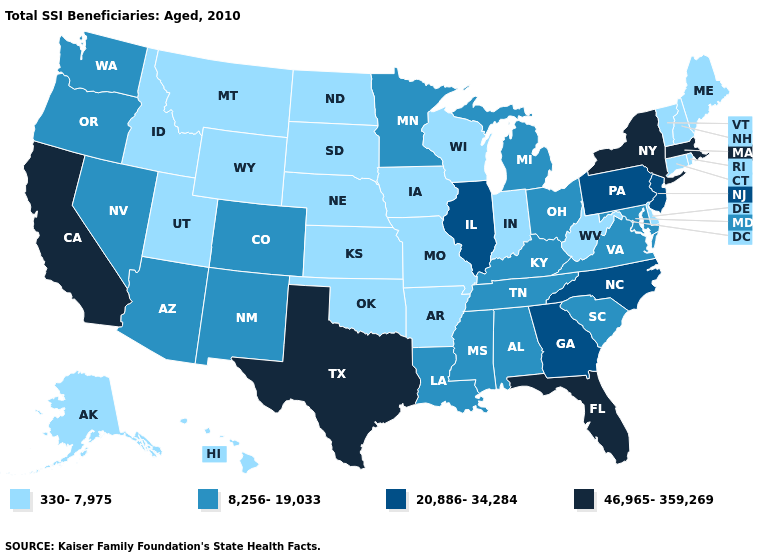Name the states that have a value in the range 8,256-19,033?
Answer briefly. Alabama, Arizona, Colorado, Kentucky, Louisiana, Maryland, Michigan, Minnesota, Mississippi, Nevada, New Mexico, Ohio, Oregon, South Carolina, Tennessee, Virginia, Washington. What is the highest value in the USA?
Short answer required. 46,965-359,269. Does North Carolina have the lowest value in the USA?
Keep it brief. No. What is the lowest value in states that border Vermont?
Concise answer only. 330-7,975. Name the states that have a value in the range 8,256-19,033?
Give a very brief answer. Alabama, Arizona, Colorado, Kentucky, Louisiana, Maryland, Michigan, Minnesota, Mississippi, Nevada, New Mexico, Ohio, Oregon, South Carolina, Tennessee, Virginia, Washington. Does the first symbol in the legend represent the smallest category?
Answer briefly. Yes. Name the states that have a value in the range 330-7,975?
Quick response, please. Alaska, Arkansas, Connecticut, Delaware, Hawaii, Idaho, Indiana, Iowa, Kansas, Maine, Missouri, Montana, Nebraska, New Hampshire, North Dakota, Oklahoma, Rhode Island, South Dakota, Utah, Vermont, West Virginia, Wisconsin, Wyoming. Name the states that have a value in the range 8,256-19,033?
Write a very short answer. Alabama, Arizona, Colorado, Kentucky, Louisiana, Maryland, Michigan, Minnesota, Mississippi, Nevada, New Mexico, Ohio, Oregon, South Carolina, Tennessee, Virginia, Washington. Which states have the lowest value in the West?
Answer briefly. Alaska, Hawaii, Idaho, Montana, Utah, Wyoming. Does the first symbol in the legend represent the smallest category?
Short answer required. Yes. Among the states that border Idaho , which have the highest value?
Be succinct. Nevada, Oregon, Washington. Does Illinois have a lower value than Arizona?
Give a very brief answer. No. Name the states that have a value in the range 46,965-359,269?
Give a very brief answer. California, Florida, Massachusetts, New York, Texas. What is the lowest value in states that border Kentucky?
Quick response, please. 330-7,975. What is the value of Indiana?
Write a very short answer. 330-7,975. 